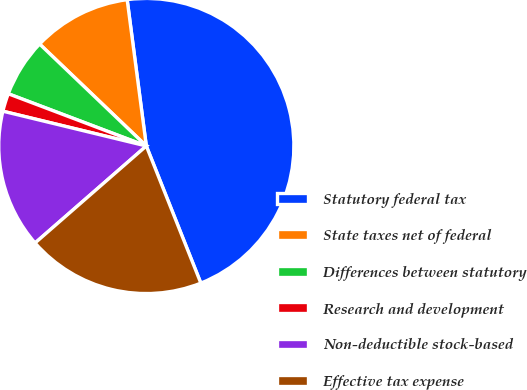Convert chart. <chart><loc_0><loc_0><loc_500><loc_500><pie_chart><fcel>Statutory federal tax<fcel>State taxes net of federal<fcel>Differences between statutory<fcel>Research and development<fcel>Non-deductible stock-based<fcel>Effective tax expense<nl><fcel>46.05%<fcel>10.79%<fcel>6.38%<fcel>1.97%<fcel>15.2%<fcel>19.61%<nl></chart> 